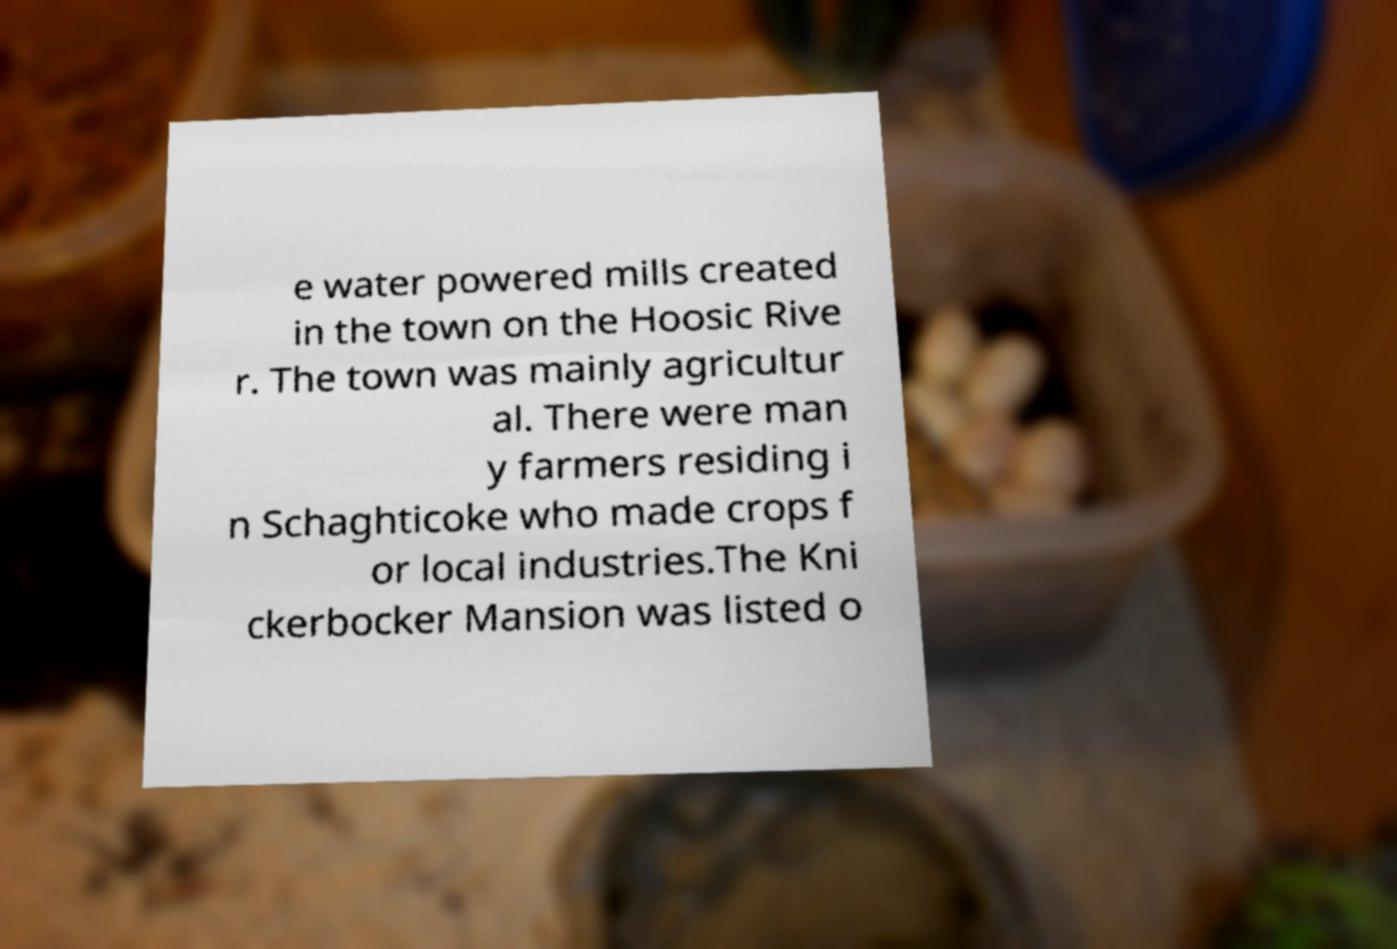Please identify and transcribe the text found in this image. e water powered mills created in the town on the Hoosic Rive r. The town was mainly agricultur al. There were man y farmers residing i n Schaghticoke who made crops f or local industries.The Kni ckerbocker Mansion was listed o 